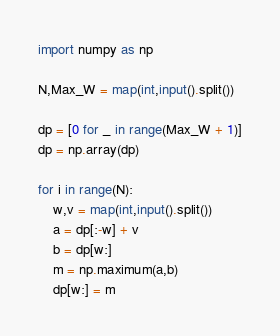Convert code to text. <code><loc_0><loc_0><loc_500><loc_500><_Python_>import numpy as np
 
N,Max_W = map(int,input().split())
 
dp = [0 for _ in range(Max_W + 1)]
dp = np.array(dp)
 
for i in range(N):
    w,v = map(int,input().split())
    a = dp[:-w] + v
    b = dp[w:]
    m = np.maximum(a,b)
    dp[w:] = m</code> 